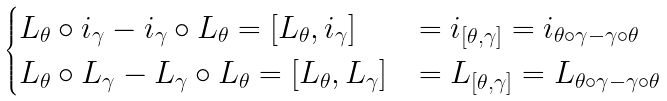<formula> <loc_0><loc_0><loc_500><loc_500>\begin{cases} L _ { \theta } \circ i _ { \gamma } - i _ { \gamma } \circ L _ { \theta } = [ L _ { \theta } , i _ { \gamma } ] & = i _ { [ \theta , \gamma ] } = i _ { \theta \circ \gamma - \gamma \circ \theta } \\ L _ { \theta } \circ L _ { \gamma } - L _ { \gamma } \circ L _ { \theta } = [ L _ { \theta } , L _ { \gamma } ] & = L _ { [ \theta , \gamma ] } = L _ { \theta \circ \gamma - \gamma \circ \theta } \end{cases}</formula> 